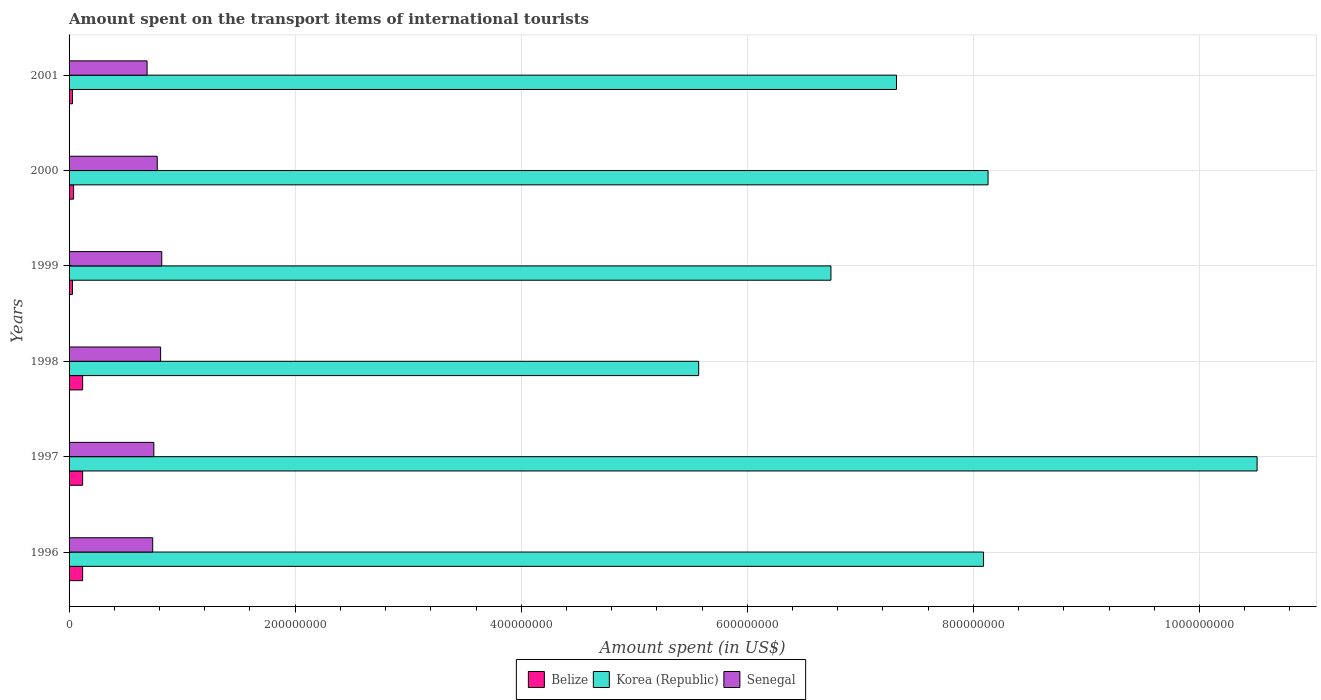How many different coloured bars are there?
Keep it short and to the point. 3. How many groups of bars are there?
Provide a succinct answer. 6. Are the number of bars per tick equal to the number of legend labels?
Ensure brevity in your answer.  Yes. How many bars are there on the 5th tick from the bottom?
Ensure brevity in your answer.  3. What is the amount spent on the transport items of international tourists in Senegal in 1996?
Offer a very short reply. 7.40e+07. Across all years, what is the maximum amount spent on the transport items of international tourists in Senegal?
Your answer should be very brief. 8.20e+07. Across all years, what is the minimum amount spent on the transport items of international tourists in Senegal?
Your answer should be compact. 6.90e+07. In which year was the amount spent on the transport items of international tourists in Korea (Republic) minimum?
Provide a short and direct response. 1998. What is the total amount spent on the transport items of international tourists in Senegal in the graph?
Ensure brevity in your answer.  4.59e+08. What is the difference between the amount spent on the transport items of international tourists in Korea (Republic) in 2000 and that in 2001?
Keep it short and to the point. 8.10e+07. What is the difference between the amount spent on the transport items of international tourists in Senegal in 1997 and the amount spent on the transport items of international tourists in Korea (Republic) in 1998?
Your answer should be very brief. -4.82e+08. What is the average amount spent on the transport items of international tourists in Korea (Republic) per year?
Offer a very short reply. 7.73e+08. In the year 1996, what is the difference between the amount spent on the transport items of international tourists in Senegal and amount spent on the transport items of international tourists in Korea (Republic)?
Provide a succinct answer. -7.35e+08. In how many years, is the amount spent on the transport items of international tourists in Senegal greater than 160000000 US$?
Offer a very short reply. 0. What is the ratio of the amount spent on the transport items of international tourists in Korea (Republic) in 1999 to that in 2001?
Provide a short and direct response. 0.92. Is the amount spent on the transport items of international tourists in Korea (Republic) in 1998 less than that in 2000?
Provide a short and direct response. Yes. What is the difference between the highest and the lowest amount spent on the transport items of international tourists in Korea (Republic)?
Provide a succinct answer. 4.94e+08. What does the 1st bar from the top in 2000 represents?
Your answer should be very brief. Senegal. What does the 3rd bar from the bottom in 1999 represents?
Your response must be concise. Senegal. Is it the case that in every year, the sum of the amount spent on the transport items of international tourists in Senegal and amount spent on the transport items of international tourists in Belize is greater than the amount spent on the transport items of international tourists in Korea (Republic)?
Offer a terse response. No. How are the legend labels stacked?
Provide a succinct answer. Horizontal. What is the title of the graph?
Keep it short and to the point. Amount spent on the transport items of international tourists. What is the label or title of the X-axis?
Provide a short and direct response. Amount spent (in US$). What is the label or title of the Y-axis?
Your answer should be very brief. Years. What is the Amount spent (in US$) of Korea (Republic) in 1996?
Your answer should be very brief. 8.09e+08. What is the Amount spent (in US$) in Senegal in 1996?
Offer a terse response. 7.40e+07. What is the Amount spent (in US$) in Korea (Republic) in 1997?
Keep it short and to the point. 1.05e+09. What is the Amount spent (in US$) of Senegal in 1997?
Your response must be concise. 7.50e+07. What is the Amount spent (in US$) in Belize in 1998?
Your answer should be very brief. 1.20e+07. What is the Amount spent (in US$) of Korea (Republic) in 1998?
Offer a very short reply. 5.57e+08. What is the Amount spent (in US$) in Senegal in 1998?
Provide a succinct answer. 8.10e+07. What is the Amount spent (in US$) of Belize in 1999?
Give a very brief answer. 3.00e+06. What is the Amount spent (in US$) in Korea (Republic) in 1999?
Offer a very short reply. 6.74e+08. What is the Amount spent (in US$) of Senegal in 1999?
Your answer should be compact. 8.20e+07. What is the Amount spent (in US$) of Belize in 2000?
Offer a terse response. 4.00e+06. What is the Amount spent (in US$) of Korea (Republic) in 2000?
Your answer should be very brief. 8.13e+08. What is the Amount spent (in US$) in Senegal in 2000?
Your response must be concise. 7.80e+07. What is the Amount spent (in US$) of Belize in 2001?
Your answer should be very brief. 3.00e+06. What is the Amount spent (in US$) of Korea (Republic) in 2001?
Offer a very short reply. 7.32e+08. What is the Amount spent (in US$) in Senegal in 2001?
Offer a terse response. 6.90e+07. Across all years, what is the maximum Amount spent (in US$) of Korea (Republic)?
Offer a very short reply. 1.05e+09. Across all years, what is the maximum Amount spent (in US$) of Senegal?
Give a very brief answer. 8.20e+07. Across all years, what is the minimum Amount spent (in US$) in Belize?
Provide a short and direct response. 3.00e+06. Across all years, what is the minimum Amount spent (in US$) in Korea (Republic)?
Ensure brevity in your answer.  5.57e+08. Across all years, what is the minimum Amount spent (in US$) in Senegal?
Your answer should be very brief. 6.90e+07. What is the total Amount spent (in US$) of Belize in the graph?
Provide a succinct answer. 4.60e+07. What is the total Amount spent (in US$) of Korea (Republic) in the graph?
Provide a succinct answer. 4.64e+09. What is the total Amount spent (in US$) in Senegal in the graph?
Ensure brevity in your answer.  4.59e+08. What is the difference between the Amount spent (in US$) of Korea (Republic) in 1996 and that in 1997?
Make the answer very short. -2.42e+08. What is the difference between the Amount spent (in US$) in Senegal in 1996 and that in 1997?
Offer a terse response. -1.00e+06. What is the difference between the Amount spent (in US$) in Korea (Republic) in 1996 and that in 1998?
Keep it short and to the point. 2.52e+08. What is the difference between the Amount spent (in US$) in Senegal in 1996 and that in 1998?
Ensure brevity in your answer.  -7.00e+06. What is the difference between the Amount spent (in US$) in Belize in 1996 and that in 1999?
Give a very brief answer. 9.00e+06. What is the difference between the Amount spent (in US$) in Korea (Republic) in 1996 and that in 1999?
Give a very brief answer. 1.35e+08. What is the difference between the Amount spent (in US$) in Senegal in 1996 and that in 1999?
Ensure brevity in your answer.  -8.00e+06. What is the difference between the Amount spent (in US$) in Korea (Republic) in 1996 and that in 2000?
Your response must be concise. -4.00e+06. What is the difference between the Amount spent (in US$) in Senegal in 1996 and that in 2000?
Give a very brief answer. -4.00e+06. What is the difference between the Amount spent (in US$) in Belize in 1996 and that in 2001?
Offer a very short reply. 9.00e+06. What is the difference between the Amount spent (in US$) of Korea (Republic) in 1996 and that in 2001?
Offer a very short reply. 7.70e+07. What is the difference between the Amount spent (in US$) of Senegal in 1996 and that in 2001?
Your answer should be compact. 5.00e+06. What is the difference between the Amount spent (in US$) of Belize in 1997 and that in 1998?
Offer a very short reply. 0. What is the difference between the Amount spent (in US$) in Korea (Republic) in 1997 and that in 1998?
Provide a succinct answer. 4.94e+08. What is the difference between the Amount spent (in US$) of Senegal in 1997 and that in 1998?
Make the answer very short. -6.00e+06. What is the difference between the Amount spent (in US$) in Belize in 1997 and that in 1999?
Your response must be concise. 9.00e+06. What is the difference between the Amount spent (in US$) in Korea (Republic) in 1997 and that in 1999?
Your response must be concise. 3.77e+08. What is the difference between the Amount spent (in US$) of Senegal in 1997 and that in 1999?
Your response must be concise. -7.00e+06. What is the difference between the Amount spent (in US$) of Korea (Republic) in 1997 and that in 2000?
Offer a very short reply. 2.38e+08. What is the difference between the Amount spent (in US$) in Belize in 1997 and that in 2001?
Give a very brief answer. 9.00e+06. What is the difference between the Amount spent (in US$) in Korea (Republic) in 1997 and that in 2001?
Provide a short and direct response. 3.19e+08. What is the difference between the Amount spent (in US$) of Belize in 1998 and that in 1999?
Provide a succinct answer. 9.00e+06. What is the difference between the Amount spent (in US$) of Korea (Republic) in 1998 and that in 1999?
Give a very brief answer. -1.17e+08. What is the difference between the Amount spent (in US$) of Belize in 1998 and that in 2000?
Keep it short and to the point. 8.00e+06. What is the difference between the Amount spent (in US$) in Korea (Republic) in 1998 and that in 2000?
Your answer should be very brief. -2.56e+08. What is the difference between the Amount spent (in US$) in Belize in 1998 and that in 2001?
Give a very brief answer. 9.00e+06. What is the difference between the Amount spent (in US$) in Korea (Republic) in 1998 and that in 2001?
Provide a short and direct response. -1.75e+08. What is the difference between the Amount spent (in US$) in Korea (Republic) in 1999 and that in 2000?
Give a very brief answer. -1.39e+08. What is the difference between the Amount spent (in US$) in Korea (Republic) in 1999 and that in 2001?
Provide a succinct answer. -5.80e+07. What is the difference between the Amount spent (in US$) in Senegal in 1999 and that in 2001?
Your response must be concise. 1.30e+07. What is the difference between the Amount spent (in US$) in Korea (Republic) in 2000 and that in 2001?
Your answer should be compact. 8.10e+07. What is the difference between the Amount spent (in US$) in Senegal in 2000 and that in 2001?
Ensure brevity in your answer.  9.00e+06. What is the difference between the Amount spent (in US$) of Belize in 1996 and the Amount spent (in US$) of Korea (Republic) in 1997?
Offer a terse response. -1.04e+09. What is the difference between the Amount spent (in US$) in Belize in 1996 and the Amount spent (in US$) in Senegal in 1997?
Your answer should be compact. -6.30e+07. What is the difference between the Amount spent (in US$) of Korea (Republic) in 1996 and the Amount spent (in US$) of Senegal in 1997?
Offer a terse response. 7.34e+08. What is the difference between the Amount spent (in US$) of Belize in 1996 and the Amount spent (in US$) of Korea (Republic) in 1998?
Offer a very short reply. -5.45e+08. What is the difference between the Amount spent (in US$) of Belize in 1996 and the Amount spent (in US$) of Senegal in 1998?
Your answer should be very brief. -6.90e+07. What is the difference between the Amount spent (in US$) of Korea (Republic) in 1996 and the Amount spent (in US$) of Senegal in 1998?
Provide a short and direct response. 7.28e+08. What is the difference between the Amount spent (in US$) in Belize in 1996 and the Amount spent (in US$) in Korea (Republic) in 1999?
Offer a terse response. -6.62e+08. What is the difference between the Amount spent (in US$) in Belize in 1996 and the Amount spent (in US$) in Senegal in 1999?
Give a very brief answer. -7.00e+07. What is the difference between the Amount spent (in US$) in Korea (Republic) in 1996 and the Amount spent (in US$) in Senegal in 1999?
Make the answer very short. 7.27e+08. What is the difference between the Amount spent (in US$) in Belize in 1996 and the Amount spent (in US$) in Korea (Republic) in 2000?
Provide a succinct answer. -8.01e+08. What is the difference between the Amount spent (in US$) of Belize in 1996 and the Amount spent (in US$) of Senegal in 2000?
Offer a terse response. -6.60e+07. What is the difference between the Amount spent (in US$) in Korea (Republic) in 1996 and the Amount spent (in US$) in Senegal in 2000?
Keep it short and to the point. 7.31e+08. What is the difference between the Amount spent (in US$) in Belize in 1996 and the Amount spent (in US$) in Korea (Republic) in 2001?
Provide a short and direct response. -7.20e+08. What is the difference between the Amount spent (in US$) in Belize in 1996 and the Amount spent (in US$) in Senegal in 2001?
Keep it short and to the point. -5.70e+07. What is the difference between the Amount spent (in US$) in Korea (Republic) in 1996 and the Amount spent (in US$) in Senegal in 2001?
Your response must be concise. 7.40e+08. What is the difference between the Amount spent (in US$) in Belize in 1997 and the Amount spent (in US$) in Korea (Republic) in 1998?
Keep it short and to the point. -5.45e+08. What is the difference between the Amount spent (in US$) in Belize in 1997 and the Amount spent (in US$) in Senegal in 1998?
Your answer should be compact. -6.90e+07. What is the difference between the Amount spent (in US$) of Korea (Republic) in 1997 and the Amount spent (in US$) of Senegal in 1998?
Your response must be concise. 9.70e+08. What is the difference between the Amount spent (in US$) in Belize in 1997 and the Amount spent (in US$) in Korea (Republic) in 1999?
Ensure brevity in your answer.  -6.62e+08. What is the difference between the Amount spent (in US$) of Belize in 1997 and the Amount spent (in US$) of Senegal in 1999?
Your response must be concise. -7.00e+07. What is the difference between the Amount spent (in US$) in Korea (Republic) in 1997 and the Amount spent (in US$) in Senegal in 1999?
Keep it short and to the point. 9.69e+08. What is the difference between the Amount spent (in US$) of Belize in 1997 and the Amount spent (in US$) of Korea (Republic) in 2000?
Your answer should be very brief. -8.01e+08. What is the difference between the Amount spent (in US$) in Belize in 1997 and the Amount spent (in US$) in Senegal in 2000?
Your response must be concise. -6.60e+07. What is the difference between the Amount spent (in US$) of Korea (Republic) in 1997 and the Amount spent (in US$) of Senegal in 2000?
Ensure brevity in your answer.  9.73e+08. What is the difference between the Amount spent (in US$) in Belize in 1997 and the Amount spent (in US$) in Korea (Republic) in 2001?
Your answer should be very brief. -7.20e+08. What is the difference between the Amount spent (in US$) of Belize in 1997 and the Amount spent (in US$) of Senegal in 2001?
Your response must be concise. -5.70e+07. What is the difference between the Amount spent (in US$) in Korea (Republic) in 1997 and the Amount spent (in US$) in Senegal in 2001?
Your response must be concise. 9.82e+08. What is the difference between the Amount spent (in US$) in Belize in 1998 and the Amount spent (in US$) in Korea (Republic) in 1999?
Provide a short and direct response. -6.62e+08. What is the difference between the Amount spent (in US$) in Belize in 1998 and the Amount spent (in US$) in Senegal in 1999?
Your answer should be compact. -7.00e+07. What is the difference between the Amount spent (in US$) in Korea (Republic) in 1998 and the Amount spent (in US$) in Senegal in 1999?
Offer a terse response. 4.75e+08. What is the difference between the Amount spent (in US$) of Belize in 1998 and the Amount spent (in US$) of Korea (Republic) in 2000?
Your answer should be very brief. -8.01e+08. What is the difference between the Amount spent (in US$) in Belize in 1998 and the Amount spent (in US$) in Senegal in 2000?
Offer a very short reply. -6.60e+07. What is the difference between the Amount spent (in US$) of Korea (Republic) in 1998 and the Amount spent (in US$) of Senegal in 2000?
Ensure brevity in your answer.  4.79e+08. What is the difference between the Amount spent (in US$) in Belize in 1998 and the Amount spent (in US$) in Korea (Republic) in 2001?
Offer a terse response. -7.20e+08. What is the difference between the Amount spent (in US$) of Belize in 1998 and the Amount spent (in US$) of Senegal in 2001?
Your response must be concise. -5.70e+07. What is the difference between the Amount spent (in US$) of Korea (Republic) in 1998 and the Amount spent (in US$) of Senegal in 2001?
Your answer should be very brief. 4.88e+08. What is the difference between the Amount spent (in US$) in Belize in 1999 and the Amount spent (in US$) in Korea (Republic) in 2000?
Ensure brevity in your answer.  -8.10e+08. What is the difference between the Amount spent (in US$) of Belize in 1999 and the Amount spent (in US$) of Senegal in 2000?
Your response must be concise. -7.50e+07. What is the difference between the Amount spent (in US$) in Korea (Republic) in 1999 and the Amount spent (in US$) in Senegal in 2000?
Ensure brevity in your answer.  5.96e+08. What is the difference between the Amount spent (in US$) in Belize in 1999 and the Amount spent (in US$) in Korea (Republic) in 2001?
Provide a succinct answer. -7.29e+08. What is the difference between the Amount spent (in US$) of Belize in 1999 and the Amount spent (in US$) of Senegal in 2001?
Keep it short and to the point. -6.60e+07. What is the difference between the Amount spent (in US$) in Korea (Republic) in 1999 and the Amount spent (in US$) in Senegal in 2001?
Offer a terse response. 6.05e+08. What is the difference between the Amount spent (in US$) in Belize in 2000 and the Amount spent (in US$) in Korea (Republic) in 2001?
Your answer should be very brief. -7.28e+08. What is the difference between the Amount spent (in US$) in Belize in 2000 and the Amount spent (in US$) in Senegal in 2001?
Provide a succinct answer. -6.50e+07. What is the difference between the Amount spent (in US$) in Korea (Republic) in 2000 and the Amount spent (in US$) in Senegal in 2001?
Make the answer very short. 7.44e+08. What is the average Amount spent (in US$) in Belize per year?
Give a very brief answer. 7.67e+06. What is the average Amount spent (in US$) in Korea (Republic) per year?
Offer a very short reply. 7.73e+08. What is the average Amount spent (in US$) of Senegal per year?
Offer a terse response. 7.65e+07. In the year 1996, what is the difference between the Amount spent (in US$) of Belize and Amount spent (in US$) of Korea (Republic)?
Your answer should be very brief. -7.97e+08. In the year 1996, what is the difference between the Amount spent (in US$) of Belize and Amount spent (in US$) of Senegal?
Offer a terse response. -6.20e+07. In the year 1996, what is the difference between the Amount spent (in US$) of Korea (Republic) and Amount spent (in US$) of Senegal?
Offer a terse response. 7.35e+08. In the year 1997, what is the difference between the Amount spent (in US$) of Belize and Amount spent (in US$) of Korea (Republic)?
Offer a very short reply. -1.04e+09. In the year 1997, what is the difference between the Amount spent (in US$) in Belize and Amount spent (in US$) in Senegal?
Keep it short and to the point. -6.30e+07. In the year 1997, what is the difference between the Amount spent (in US$) of Korea (Republic) and Amount spent (in US$) of Senegal?
Your answer should be compact. 9.76e+08. In the year 1998, what is the difference between the Amount spent (in US$) in Belize and Amount spent (in US$) in Korea (Republic)?
Keep it short and to the point. -5.45e+08. In the year 1998, what is the difference between the Amount spent (in US$) in Belize and Amount spent (in US$) in Senegal?
Provide a short and direct response. -6.90e+07. In the year 1998, what is the difference between the Amount spent (in US$) in Korea (Republic) and Amount spent (in US$) in Senegal?
Provide a short and direct response. 4.76e+08. In the year 1999, what is the difference between the Amount spent (in US$) in Belize and Amount spent (in US$) in Korea (Republic)?
Make the answer very short. -6.71e+08. In the year 1999, what is the difference between the Amount spent (in US$) in Belize and Amount spent (in US$) in Senegal?
Give a very brief answer. -7.90e+07. In the year 1999, what is the difference between the Amount spent (in US$) of Korea (Republic) and Amount spent (in US$) of Senegal?
Ensure brevity in your answer.  5.92e+08. In the year 2000, what is the difference between the Amount spent (in US$) in Belize and Amount spent (in US$) in Korea (Republic)?
Give a very brief answer. -8.09e+08. In the year 2000, what is the difference between the Amount spent (in US$) in Belize and Amount spent (in US$) in Senegal?
Make the answer very short. -7.40e+07. In the year 2000, what is the difference between the Amount spent (in US$) in Korea (Republic) and Amount spent (in US$) in Senegal?
Provide a succinct answer. 7.35e+08. In the year 2001, what is the difference between the Amount spent (in US$) in Belize and Amount spent (in US$) in Korea (Republic)?
Keep it short and to the point. -7.29e+08. In the year 2001, what is the difference between the Amount spent (in US$) of Belize and Amount spent (in US$) of Senegal?
Offer a terse response. -6.60e+07. In the year 2001, what is the difference between the Amount spent (in US$) in Korea (Republic) and Amount spent (in US$) in Senegal?
Offer a very short reply. 6.63e+08. What is the ratio of the Amount spent (in US$) of Belize in 1996 to that in 1997?
Your response must be concise. 1. What is the ratio of the Amount spent (in US$) of Korea (Republic) in 1996 to that in 1997?
Provide a short and direct response. 0.77. What is the ratio of the Amount spent (in US$) in Senegal in 1996 to that in 1997?
Offer a very short reply. 0.99. What is the ratio of the Amount spent (in US$) in Korea (Republic) in 1996 to that in 1998?
Your answer should be compact. 1.45. What is the ratio of the Amount spent (in US$) of Senegal in 1996 to that in 1998?
Make the answer very short. 0.91. What is the ratio of the Amount spent (in US$) of Korea (Republic) in 1996 to that in 1999?
Provide a short and direct response. 1.2. What is the ratio of the Amount spent (in US$) in Senegal in 1996 to that in 1999?
Keep it short and to the point. 0.9. What is the ratio of the Amount spent (in US$) of Belize in 1996 to that in 2000?
Your response must be concise. 3. What is the ratio of the Amount spent (in US$) of Senegal in 1996 to that in 2000?
Your response must be concise. 0.95. What is the ratio of the Amount spent (in US$) in Korea (Republic) in 1996 to that in 2001?
Make the answer very short. 1.11. What is the ratio of the Amount spent (in US$) of Senegal in 1996 to that in 2001?
Your answer should be compact. 1.07. What is the ratio of the Amount spent (in US$) in Belize in 1997 to that in 1998?
Provide a succinct answer. 1. What is the ratio of the Amount spent (in US$) in Korea (Republic) in 1997 to that in 1998?
Make the answer very short. 1.89. What is the ratio of the Amount spent (in US$) in Senegal in 1997 to that in 1998?
Provide a succinct answer. 0.93. What is the ratio of the Amount spent (in US$) in Korea (Republic) in 1997 to that in 1999?
Provide a short and direct response. 1.56. What is the ratio of the Amount spent (in US$) in Senegal in 1997 to that in 1999?
Keep it short and to the point. 0.91. What is the ratio of the Amount spent (in US$) of Korea (Republic) in 1997 to that in 2000?
Offer a very short reply. 1.29. What is the ratio of the Amount spent (in US$) in Senegal in 1997 to that in 2000?
Ensure brevity in your answer.  0.96. What is the ratio of the Amount spent (in US$) of Belize in 1997 to that in 2001?
Make the answer very short. 4. What is the ratio of the Amount spent (in US$) in Korea (Republic) in 1997 to that in 2001?
Your answer should be compact. 1.44. What is the ratio of the Amount spent (in US$) in Senegal in 1997 to that in 2001?
Provide a short and direct response. 1.09. What is the ratio of the Amount spent (in US$) in Korea (Republic) in 1998 to that in 1999?
Your answer should be very brief. 0.83. What is the ratio of the Amount spent (in US$) of Belize in 1998 to that in 2000?
Offer a terse response. 3. What is the ratio of the Amount spent (in US$) in Korea (Republic) in 1998 to that in 2000?
Ensure brevity in your answer.  0.69. What is the ratio of the Amount spent (in US$) in Korea (Republic) in 1998 to that in 2001?
Offer a very short reply. 0.76. What is the ratio of the Amount spent (in US$) in Senegal in 1998 to that in 2001?
Keep it short and to the point. 1.17. What is the ratio of the Amount spent (in US$) of Korea (Republic) in 1999 to that in 2000?
Offer a terse response. 0.83. What is the ratio of the Amount spent (in US$) in Senegal in 1999 to that in 2000?
Give a very brief answer. 1.05. What is the ratio of the Amount spent (in US$) of Korea (Republic) in 1999 to that in 2001?
Provide a short and direct response. 0.92. What is the ratio of the Amount spent (in US$) in Senegal in 1999 to that in 2001?
Your answer should be compact. 1.19. What is the ratio of the Amount spent (in US$) of Belize in 2000 to that in 2001?
Offer a very short reply. 1.33. What is the ratio of the Amount spent (in US$) of Korea (Republic) in 2000 to that in 2001?
Your answer should be very brief. 1.11. What is the ratio of the Amount spent (in US$) in Senegal in 2000 to that in 2001?
Keep it short and to the point. 1.13. What is the difference between the highest and the second highest Amount spent (in US$) of Korea (Republic)?
Your response must be concise. 2.38e+08. What is the difference between the highest and the lowest Amount spent (in US$) of Belize?
Your answer should be compact. 9.00e+06. What is the difference between the highest and the lowest Amount spent (in US$) in Korea (Republic)?
Make the answer very short. 4.94e+08. What is the difference between the highest and the lowest Amount spent (in US$) of Senegal?
Keep it short and to the point. 1.30e+07. 